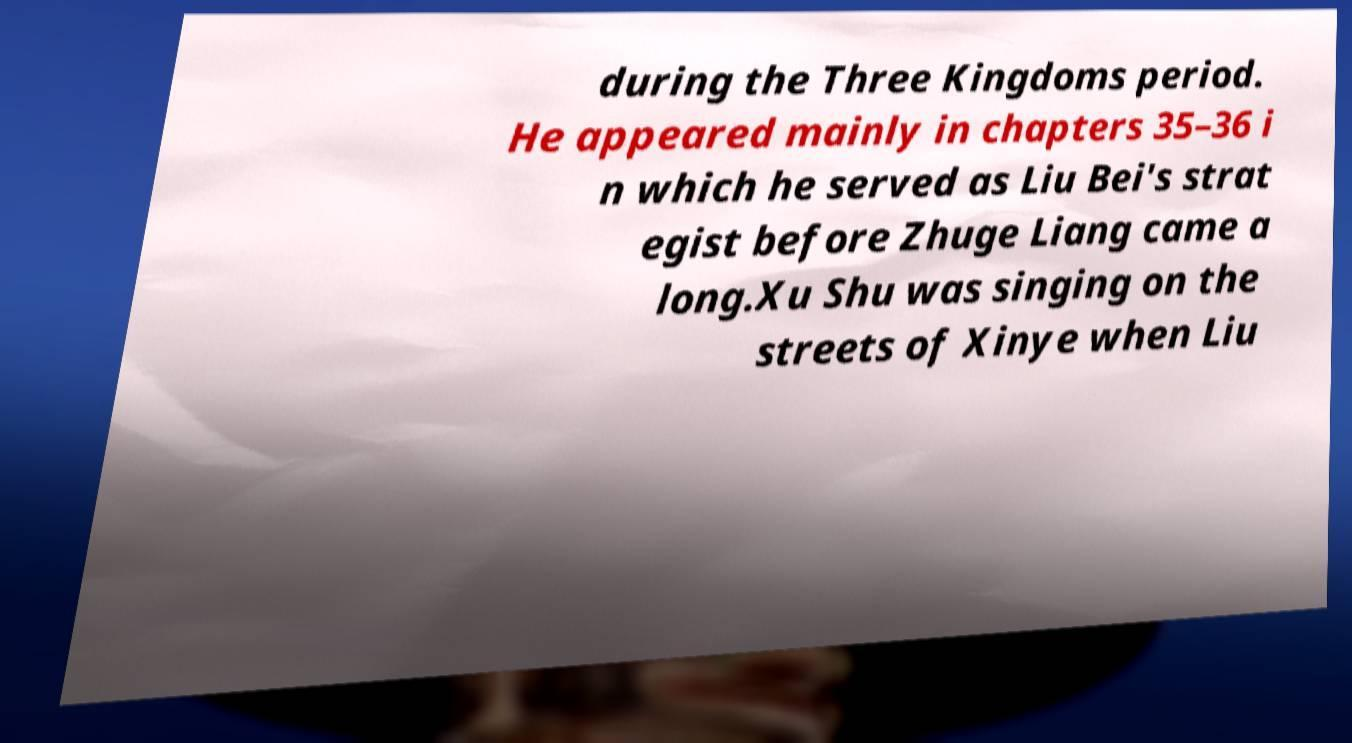For documentation purposes, I need the text within this image transcribed. Could you provide that? during the Three Kingdoms period. He appeared mainly in chapters 35–36 i n which he served as Liu Bei's strat egist before Zhuge Liang came a long.Xu Shu was singing on the streets of Xinye when Liu 